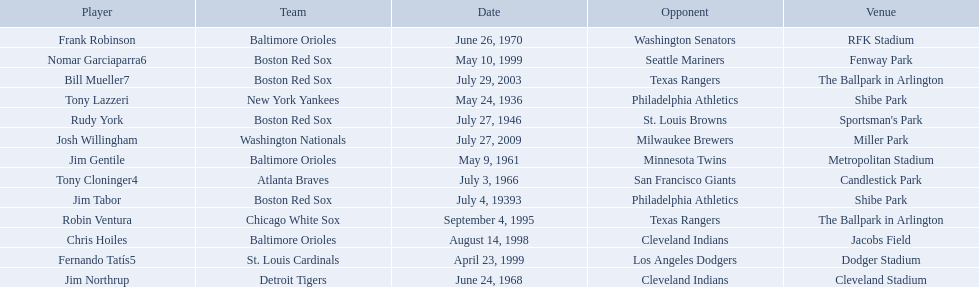What venue did detroit play cleveland in? Cleveland Stadium. Who was the player? Jim Northrup. What date did they play? June 24, 1968. Which teams played between the years 1960 and 1970? Baltimore Orioles, Atlanta Braves, Detroit Tigers, Baltimore Orioles. Of these teams that played, which ones played against the cleveland indians? Detroit Tigers. On what day did these two teams play? June 24, 1968. 